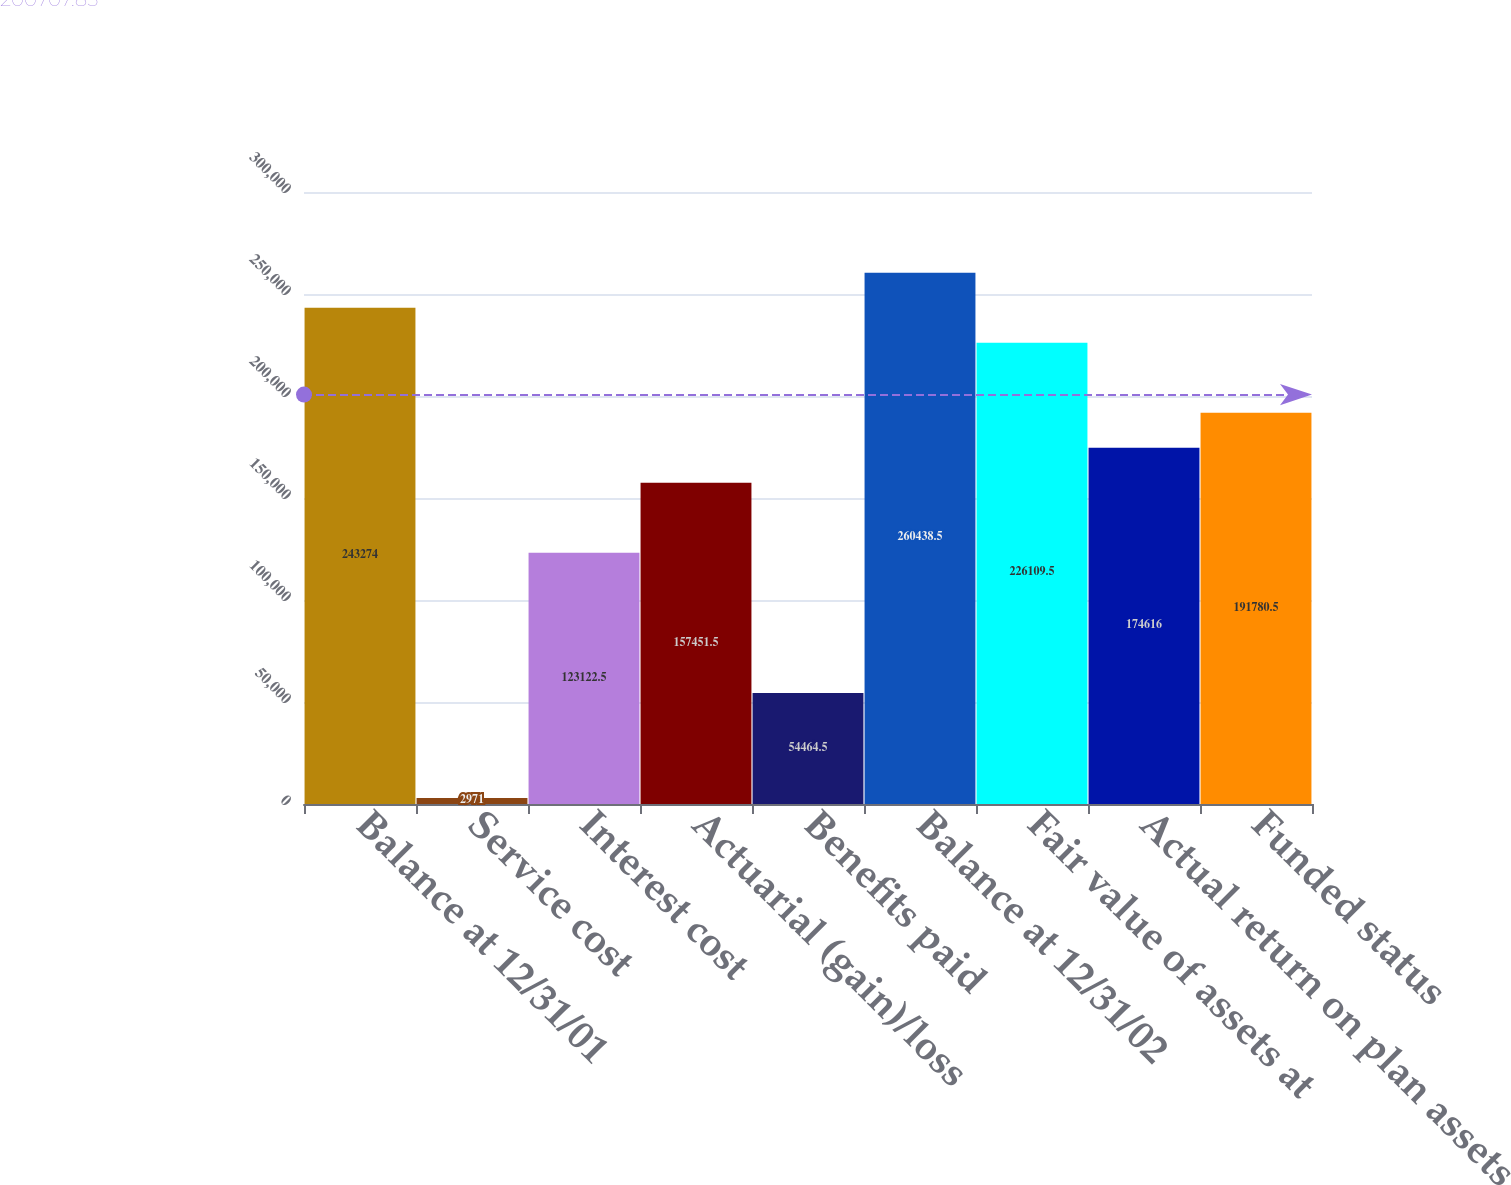Convert chart. <chart><loc_0><loc_0><loc_500><loc_500><bar_chart><fcel>Balance at 12/31/01<fcel>Service cost<fcel>Interest cost<fcel>Actuarial (gain)/loss<fcel>Benefits paid<fcel>Balance at 12/31/02<fcel>Fair value of assets at<fcel>Actual return on plan assets<fcel>Funded status<nl><fcel>243274<fcel>2971<fcel>123122<fcel>157452<fcel>54464.5<fcel>260438<fcel>226110<fcel>174616<fcel>191780<nl></chart> 